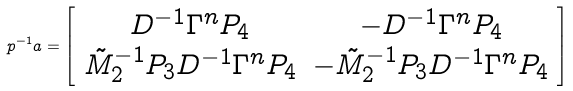<formula> <loc_0><loc_0><loc_500><loc_500>\L p ^ { - 1 } \L a = \left [ \begin{array} { c c } D ^ { - 1 } \Gamma ^ { n } P _ { 4 } & - D ^ { - 1 } \Gamma ^ { n } P _ { 4 } \\ \tilde { M } _ { 2 } ^ { - 1 } P _ { 3 } D ^ { - 1 } \Gamma ^ { n } P _ { 4 } & - \tilde { M } _ { 2 } ^ { - 1 } P _ { 3 } D ^ { - 1 } \Gamma ^ { n } P _ { 4 } \end{array} \right ]</formula> 